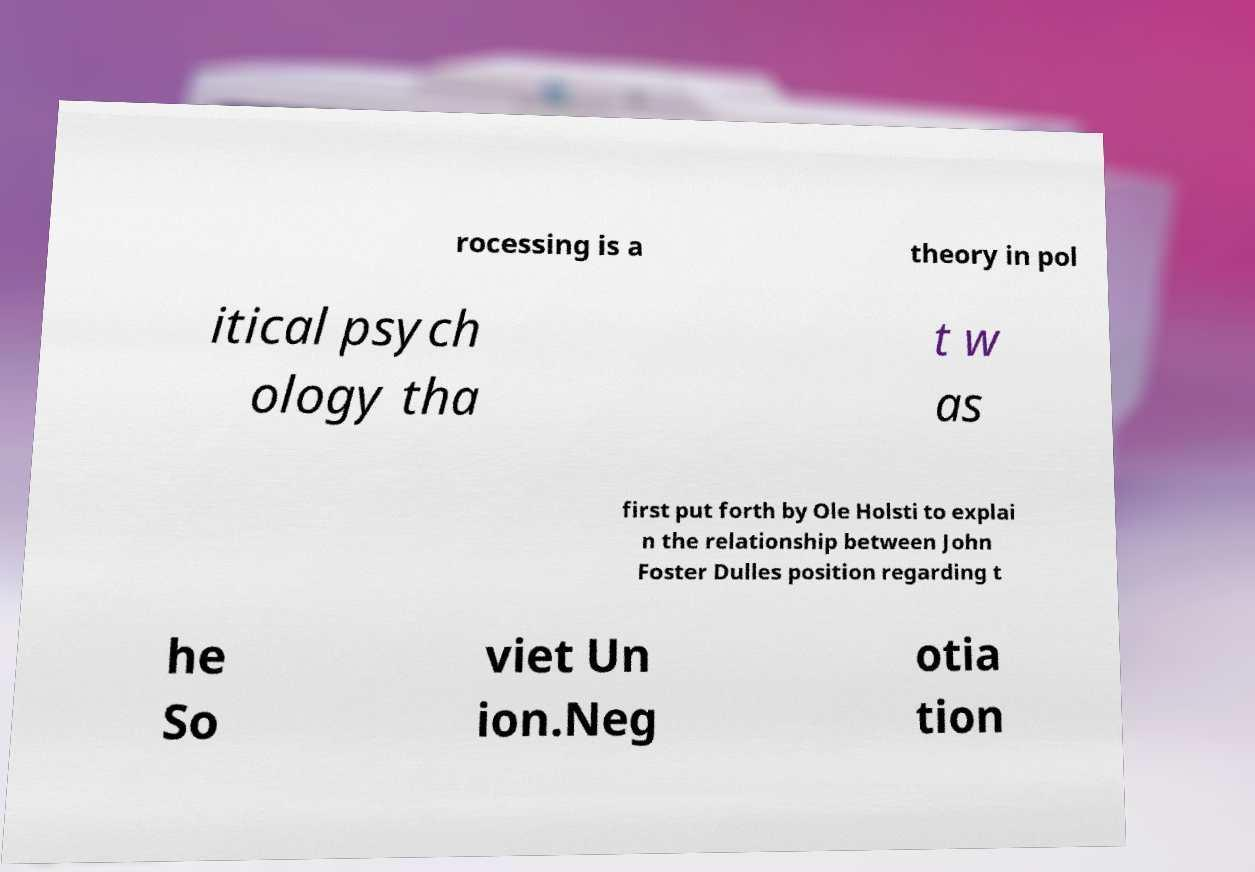Please read and relay the text visible in this image. What does it say? rocessing is a theory in pol itical psych ology tha t w as first put forth by Ole Holsti to explai n the relationship between John Foster Dulles position regarding t he So viet Un ion.Neg otia tion 